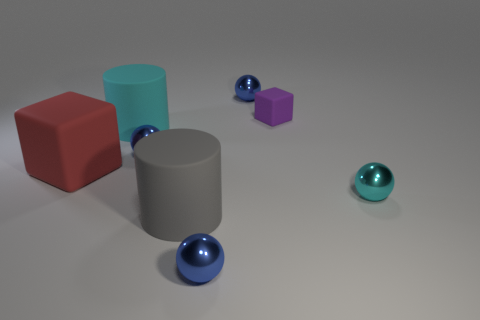There is a big cyan thing that is the same material as the small purple block; what is its shape?
Offer a terse response. Cylinder. Is the number of cylinders that are on the right side of the big cyan matte object less than the number of big gray matte things?
Make the answer very short. No. What is the color of the thing that is on the right side of the tiny purple object?
Your answer should be compact. Cyan. Is there a big red object of the same shape as the cyan rubber object?
Keep it short and to the point. No. How many large matte objects have the same shape as the small cyan thing?
Provide a succinct answer. 0. Is the color of the tiny cube the same as the large cube?
Give a very brief answer. No. Are there fewer big gray cylinders than big things?
Offer a very short reply. Yes. What material is the tiny blue thing that is on the left side of the gray cylinder?
Your answer should be very brief. Metal. There is a cyan sphere that is the same size as the purple cube; what is it made of?
Ensure brevity in your answer.  Metal. There is a big cylinder that is in front of the cylinder behind the cylinder right of the cyan cylinder; what is it made of?
Make the answer very short. Rubber. 